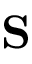<formula> <loc_0><loc_0><loc_500><loc_500>S</formula> 